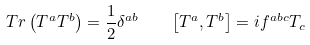<formula> <loc_0><loc_0><loc_500><loc_500>T r \left ( T ^ { a } T ^ { b } \right ) = \frac { 1 } { 2 } \delta ^ { a b } \quad \left [ T ^ { a } , T ^ { b } \right ] = i f ^ { a b c } T _ { c }</formula> 